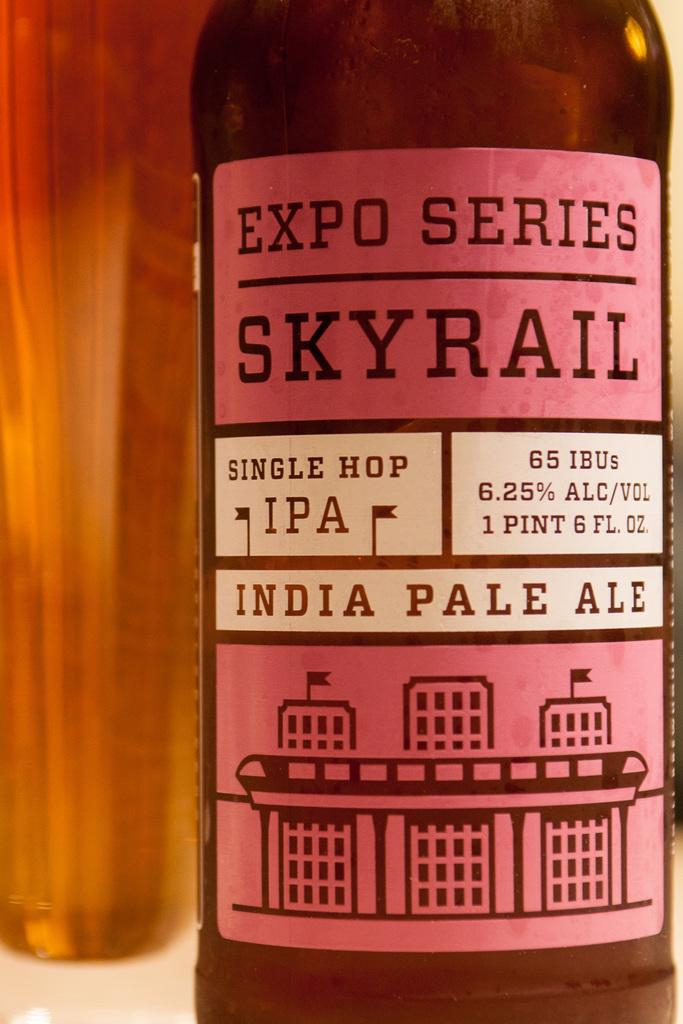Provide a one-sentence caption for the provided image. A bottle of Indian pale ale has a pink label which shows the alcohol content as 6.25%. 